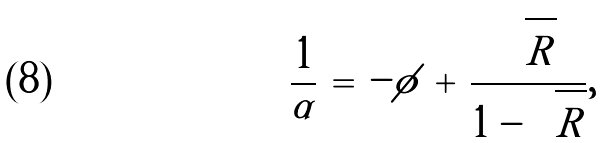<formula> <loc_0><loc_0><loc_500><loc_500>\frac { 1 } { \alpha } \, = \, - \phi \, + \, \frac { \sqrt { R } } { 1 - \sqrt { R } } ,</formula> 